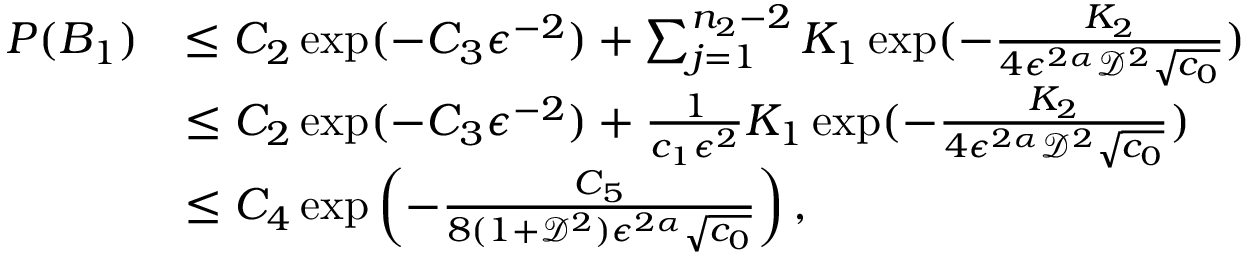Convert formula to latex. <formula><loc_0><loc_0><loc_500><loc_500>\begin{array} { r l } { P ( B _ { 1 } ) } & { \leq C _ { 2 } \exp ( - C _ { 3 } \epsilon ^ { - 2 } ) + \sum _ { j = 1 } ^ { n _ { 2 } - 2 } K _ { 1 } \exp ( - \frac { K _ { 2 } } { 4 \epsilon ^ { 2 \alpha } \mathcal { D } ^ { 2 } \sqrt { c _ { 0 } } } ) } \\ & { \leq C _ { 2 } \exp ( - C _ { 3 } \epsilon ^ { - 2 } ) + \frac { 1 } { c _ { 1 } \epsilon ^ { 2 } } K _ { 1 } \exp ( - \frac { K _ { 2 } } { 4 \epsilon ^ { 2 \alpha } \mathcal { D } ^ { 2 } \sqrt { c _ { 0 } } } ) } \\ & { \leq C _ { 4 } \exp \left ( - \frac { C _ { 5 } } { 8 ( 1 + \mathcal { D } ^ { 2 } ) \epsilon ^ { 2 \alpha } \sqrt { c _ { 0 } } } \right ) , } \end{array}</formula> 